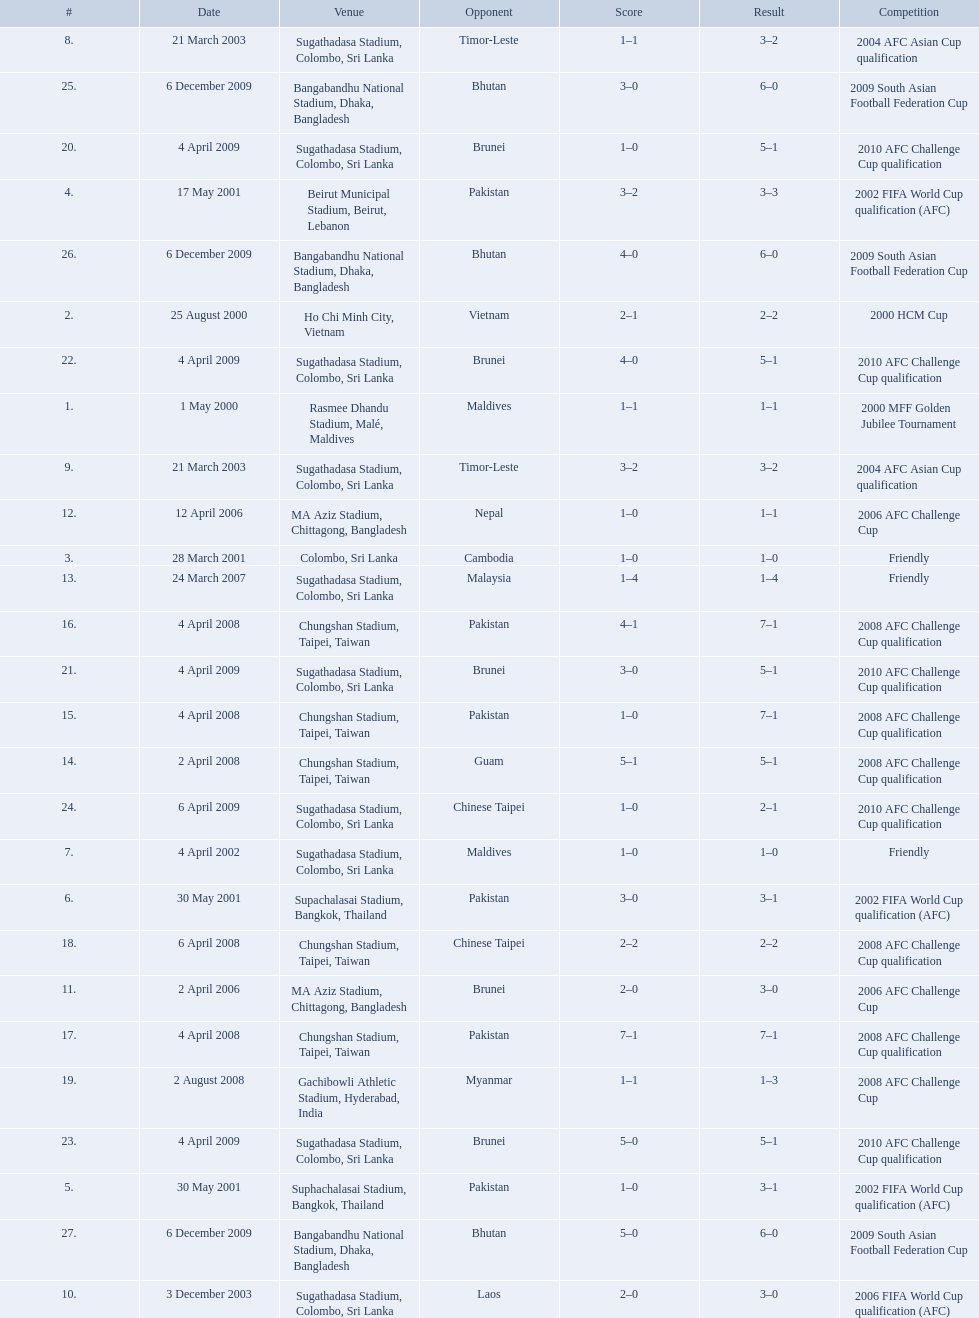What venues are listed? Rasmee Dhandu Stadium, Malé, Maldives, Ho Chi Minh City, Vietnam, Colombo, Sri Lanka, Beirut Municipal Stadium, Beirut, Lebanon, Suphachalasai Stadium, Bangkok, Thailand, MA Aziz Stadium, Chittagong, Bangladesh, Sugathadasa Stadium, Colombo, Sri Lanka, Chungshan Stadium, Taipei, Taiwan, Gachibowli Athletic Stadium, Hyderabad, India, Sugathadasa Stadium, Colombo, Sri Lanka, Bangabandhu National Stadium, Dhaka, Bangladesh. Which is top listed? Rasmee Dhandu Stadium, Malé, Maldives. What are the venues Rasmee Dhandu Stadium, Malé, Maldives, Ho Chi Minh City, Vietnam, Colombo, Sri Lanka, Beirut Municipal Stadium, Beirut, Lebanon, Suphachalasai Stadium, Bangkok, Thailand, Supachalasai Stadium, Bangkok, Thailand, Sugathadasa Stadium, Colombo, Sri Lanka, Sugathadasa Stadium, Colombo, Sri Lanka, Sugathadasa Stadium, Colombo, Sri Lanka, Sugathadasa Stadium, Colombo, Sri Lanka, MA Aziz Stadium, Chittagong, Bangladesh, MA Aziz Stadium, Chittagong, Bangladesh, Sugathadasa Stadium, Colombo, Sri Lanka, Chungshan Stadium, Taipei, Taiwan, Chungshan Stadium, Taipei, Taiwan, Chungshan Stadium, Taipei, Taiwan, Chungshan Stadium, Taipei, Taiwan, Chungshan Stadium, Taipei, Taiwan, Gachibowli Athletic Stadium, Hyderabad, India, Sugathadasa Stadium, Colombo, Sri Lanka, Sugathadasa Stadium, Colombo, Sri Lanka, Sugathadasa Stadium, Colombo, Sri Lanka, Sugathadasa Stadium, Colombo, Sri Lanka, Sugathadasa Stadium, Colombo, Sri Lanka, Bangabandhu National Stadium, Dhaka, Bangladesh, Bangabandhu National Stadium, Dhaka, Bangladesh, Bangabandhu National Stadium, Dhaka, Bangladesh. What are the #'s? 1., 2., 3., 4., 5., 6., 7., 8., 9., 10., 11., 12., 13., 14., 15., 16., 17., 18., 19., 20., 21., 22., 23., 24., 25., 26., 27. Which one is #1? Rasmee Dhandu Stadium, Malé, Maldives. 